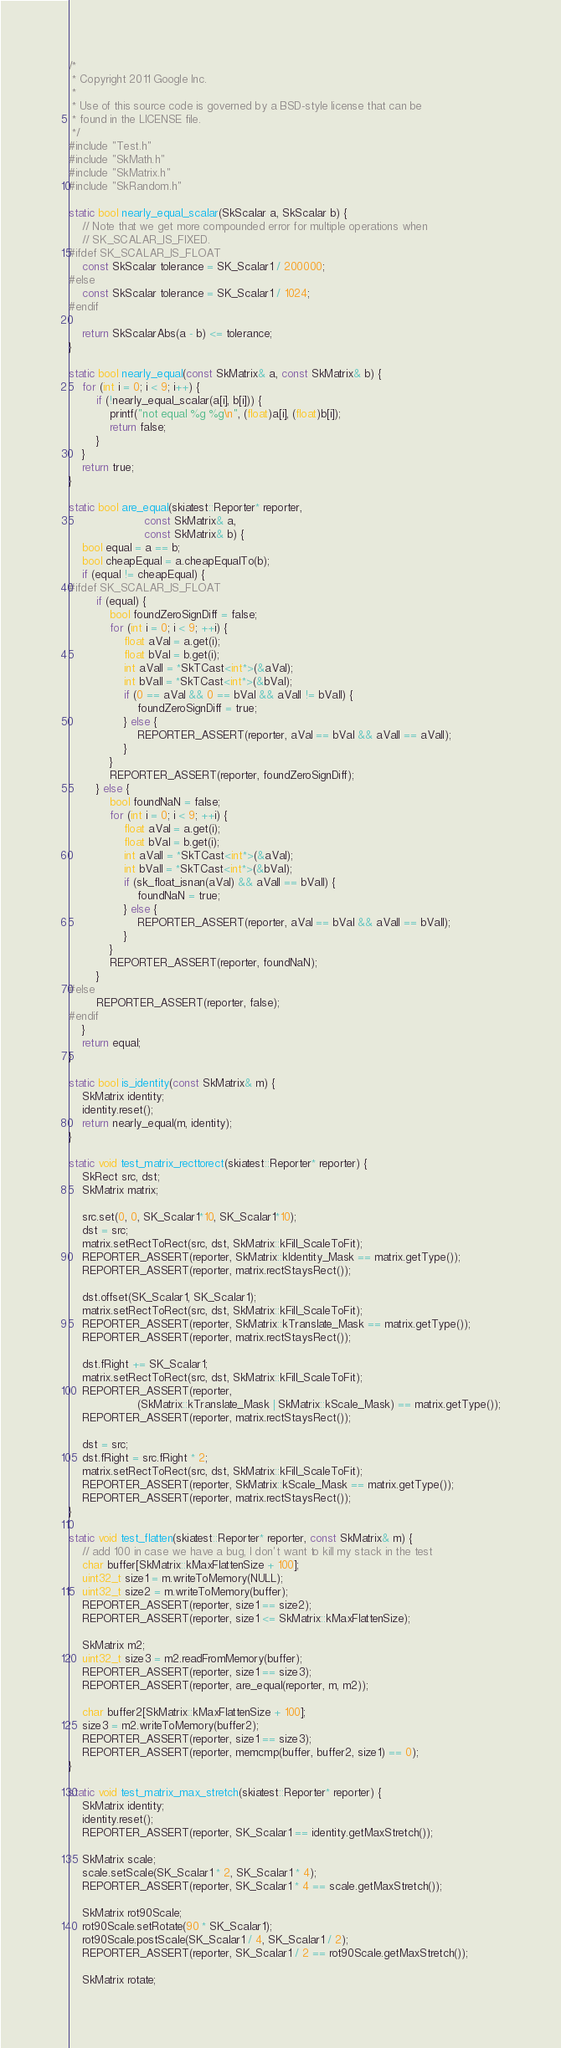Convert code to text. <code><loc_0><loc_0><loc_500><loc_500><_C++_>
/*
 * Copyright 2011 Google Inc.
 *
 * Use of this source code is governed by a BSD-style license that can be
 * found in the LICENSE file.
 */
#include "Test.h"
#include "SkMath.h"
#include "SkMatrix.h"
#include "SkRandom.h"

static bool nearly_equal_scalar(SkScalar a, SkScalar b) {
    // Note that we get more compounded error for multiple operations when
    // SK_SCALAR_IS_FIXED.
#ifdef SK_SCALAR_IS_FLOAT
    const SkScalar tolerance = SK_Scalar1 / 200000;
#else
    const SkScalar tolerance = SK_Scalar1 / 1024;
#endif

    return SkScalarAbs(a - b) <= tolerance;
}

static bool nearly_equal(const SkMatrix& a, const SkMatrix& b) {
    for (int i = 0; i < 9; i++) {
        if (!nearly_equal_scalar(a[i], b[i])) {
            printf("not equal %g %g\n", (float)a[i], (float)b[i]);
            return false;
        }
    }
    return true;
}

static bool are_equal(skiatest::Reporter* reporter,
                      const SkMatrix& a,
                      const SkMatrix& b) {
    bool equal = a == b;
    bool cheapEqual = a.cheapEqualTo(b);
    if (equal != cheapEqual) {
#ifdef SK_SCALAR_IS_FLOAT
        if (equal) {
            bool foundZeroSignDiff = false;
            for (int i = 0; i < 9; ++i) {
                float aVal = a.get(i);
                float bVal = b.get(i);
                int aValI = *SkTCast<int*>(&aVal);
                int bValI = *SkTCast<int*>(&bVal);
                if (0 == aVal && 0 == bVal && aValI != bValI) {
                    foundZeroSignDiff = true;
                } else {
                    REPORTER_ASSERT(reporter, aVal == bVal && aValI == aValI);
                }
            }
            REPORTER_ASSERT(reporter, foundZeroSignDiff);
        } else {
            bool foundNaN = false;
            for (int i = 0; i < 9; ++i) {
                float aVal = a.get(i);
                float bVal = b.get(i);
                int aValI = *SkTCast<int*>(&aVal);
                int bValI = *SkTCast<int*>(&bVal);
                if (sk_float_isnan(aVal) && aValI == bValI) {
                    foundNaN = true;
                } else {
                    REPORTER_ASSERT(reporter, aVal == bVal && aValI == bValI);
                }
            }
            REPORTER_ASSERT(reporter, foundNaN);
        }
#else
        REPORTER_ASSERT(reporter, false);
#endif
    }
    return equal;
}

static bool is_identity(const SkMatrix& m) {
    SkMatrix identity;
    identity.reset();
    return nearly_equal(m, identity);
}

static void test_matrix_recttorect(skiatest::Reporter* reporter) {
    SkRect src, dst;
    SkMatrix matrix;

    src.set(0, 0, SK_Scalar1*10, SK_Scalar1*10);
    dst = src;
    matrix.setRectToRect(src, dst, SkMatrix::kFill_ScaleToFit);
    REPORTER_ASSERT(reporter, SkMatrix::kIdentity_Mask == matrix.getType());
    REPORTER_ASSERT(reporter, matrix.rectStaysRect());

    dst.offset(SK_Scalar1, SK_Scalar1);
    matrix.setRectToRect(src, dst, SkMatrix::kFill_ScaleToFit);
    REPORTER_ASSERT(reporter, SkMatrix::kTranslate_Mask == matrix.getType());
    REPORTER_ASSERT(reporter, matrix.rectStaysRect());

    dst.fRight += SK_Scalar1;
    matrix.setRectToRect(src, dst, SkMatrix::kFill_ScaleToFit);
    REPORTER_ASSERT(reporter,
                    (SkMatrix::kTranslate_Mask | SkMatrix::kScale_Mask) == matrix.getType());
    REPORTER_ASSERT(reporter, matrix.rectStaysRect());

    dst = src;
    dst.fRight = src.fRight * 2;
    matrix.setRectToRect(src, dst, SkMatrix::kFill_ScaleToFit);
    REPORTER_ASSERT(reporter, SkMatrix::kScale_Mask == matrix.getType());
    REPORTER_ASSERT(reporter, matrix.rectStaysRect());
}

static void test_flatten(skiatest::Reporter* reporter, const SkMatrix& m) {
    // add 100 in case we have a bug, I don't want to kill my stack in the test
    char buffer[SkMatrix::kMaxFlattenSize + 100];
    uint32_t size1 = m.writeToMemory(NULL);
    uint32_t size2 = m.writeToMemory(buffer);
    REPORTER_ASSERT(reporter, size1 == size2);
    REPORTER_ASSERT(reporter, size1 <= SkMatrix::kMaxFlattenSize);

    SkMatrix m2;
    uint32_t size3 = m2.readFromMemory(buffer);
    REPORTER_ASSERT(reporter, size1 == size3);
    REPORTER_ASSERT(reporter, are_equal(reporter, m, m2));

    char buffer2[SkMatrix::kMaxFlattenSize + 100];
    size3 = m2.writeToMemory(buffer2);
    REPORTER_ASSERT(reporter, size1 == size3);
    REPORTER_ASSERT(reporter, memcmp(buffer, buffer2, size1) == 0);
}

static void test_matrix_max_stretch(skiatest::Reporter* reporter) {
    SkMatrix identity;
    identity.reset();
    REPORTER_ASSERT(reporter, SK_Scalar1 == identity.getMaxStretch());

    SkMatrix scale;
    scale.setScale(SK_Scalar1 * 2, SK_Scalar1 * 4);
    REPORTER_ASSERT(reporter, SK_Scalar1 * 4 == scale.getMaxStretch());

    SkMatrix rot90Scale;
    rot90Scale.setRotate(90 * SK_Scalar1);
    rot90Scale.postScale(SK_Scalar1 / 4, SK_Scalar1 / 2);
    REPORTER_ASSERT(reporter, SK_Scalar1 / 2 == rot90Scale.getMaxStretch());

    SkMatrix rotate;</code> 